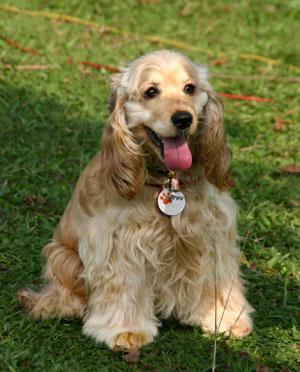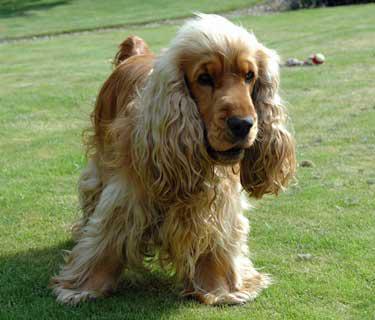The first image is the image on the left, the second image is the image on the right. Given the left and right images, does the statement "The image on the right contains a dark colored dog." hold true? Answer yes or no. No. 